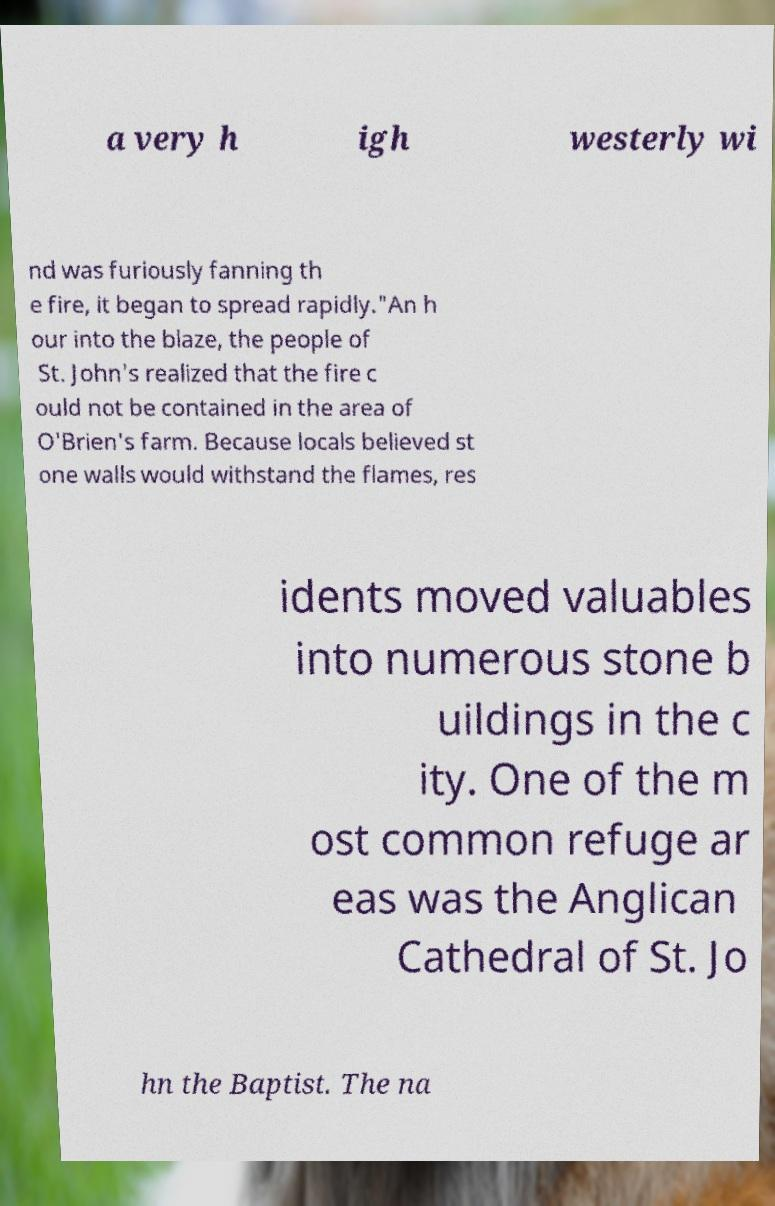Please identify and transcribe the text found in this image. a very h igh westerly wi nd was furiously fanning th e fire, it began to spread rapidly."An h our into the blaze, the people of St. John's realized that the fire c ould not be contained in the area of O'Brien's farm. Because locals believed st one walls would withstand the flames, res idents moved valuables into numerous stone b uildings in the c ity. One of the m ost common refuge ar eas was the Anglican Cathedral of St. Jo hn the Baptist. The na 